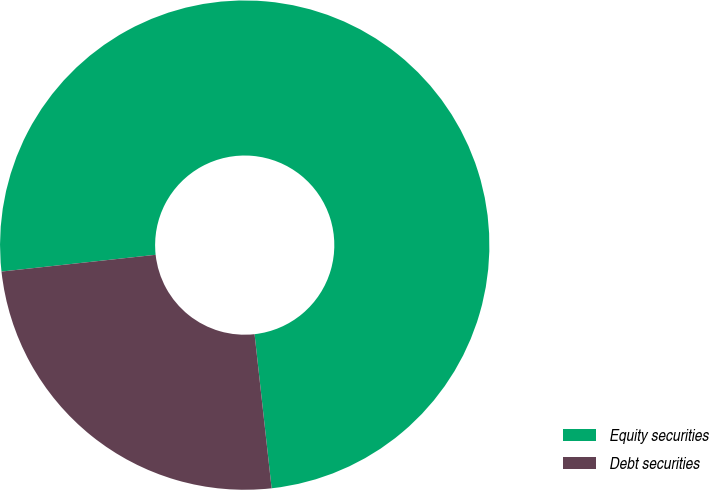Convert chart to OTSL. <chart><loc_0><loc_0><loc_500><loc_500><pie_chart><fcel>Equity securities<fcel>Debt securities<nl><fcel>74.97%<fcel>25.03%<nl></chart> 